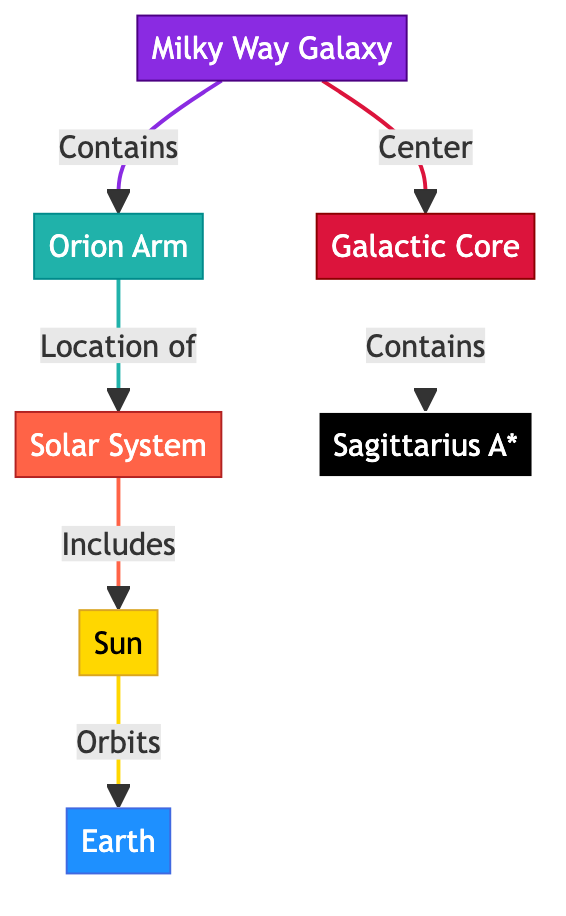What is the main galaxy depicted in the diagram? The diagram shows the "Milky Way Galaxy" as the primary focus. This can be identified as the first node in the diagram and is labeled prominently.
Answer: Milky Way Galaxy What is the location of our Solar System within the Milky Way? The Solar System is located within the "Orion Arm." This is indicated by a direct connection from "Milky Way Galaxy" to "Orion Arm."
Answer: Orion Arm How many nodes are connected to the Sun? The Sun has one direct connection, which is to the Earth, as shown by the connection from "Sun" to "Earth." Thus, there is only one node directly connected to the Sun.
Answer: 1 What is at the center of the Milky Way Galaxy? The "Galactic Core" is depicted at the center of the Milky Way Galaxy. This can be determined from the connection indicating that it is the central part of the Milky Way.
Answer: Galactic Core What type of celestial object is Sagittarius A*? In the diagram, "Sagittarius A*" is classified as a "black hole." This is indicated by the specific labeling and coloring associated with that node.
Answer: black hole What does the Solar System include? The Solar System includes the "Sun," which is indicated by a direct link from "Solar System" to "Sun." This suggests that the Sun is a fundamental component of the Solar System.
Answer: Sun How is Earth related to the Sun? The relationship shown in the diagram indicates that the Earth "orbits" the Sun. This connection demonstrates the gravitational relationship between these two celestial bodies.
Answer: orbits What component does the galactic core contain? The galactic core contains "Sagittarius A*." This is specifically stated in the diagram with the connection directly linking "Galactic Core" to "Sagittarius A*."
Answer: Sagittarius A* What color is used to represent the Milky Way Galaxy? The Milky Way Galaxy is represented in a shade of violet, specifically using the color code indicated in the diagram's class definition.
Answer: violet 